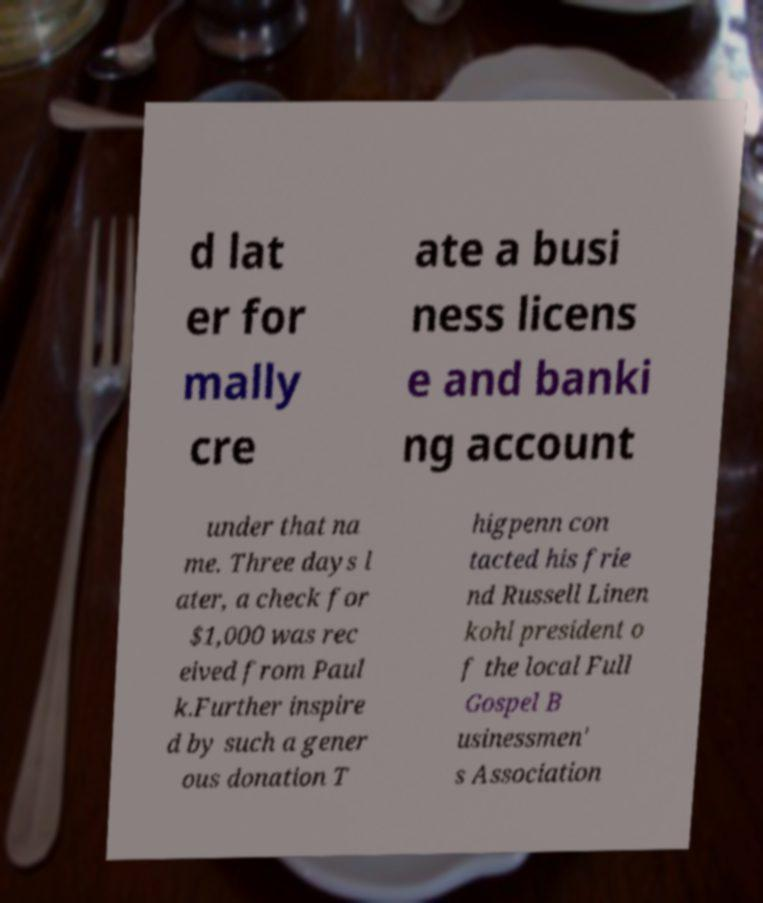Could you assist in decoding the text presented in this image and type it out clearly? d lat er for mally cre ate a busi ness licens e and banki ng account under that na me. Three days l ater, a check for $1,000 was rec eived from Paul k.Further inspire d by such a gener ous donation T higpenn con tacted his frie nd Russell Linen kohl president o f the local Full Gospel B usinessmen' s Association 